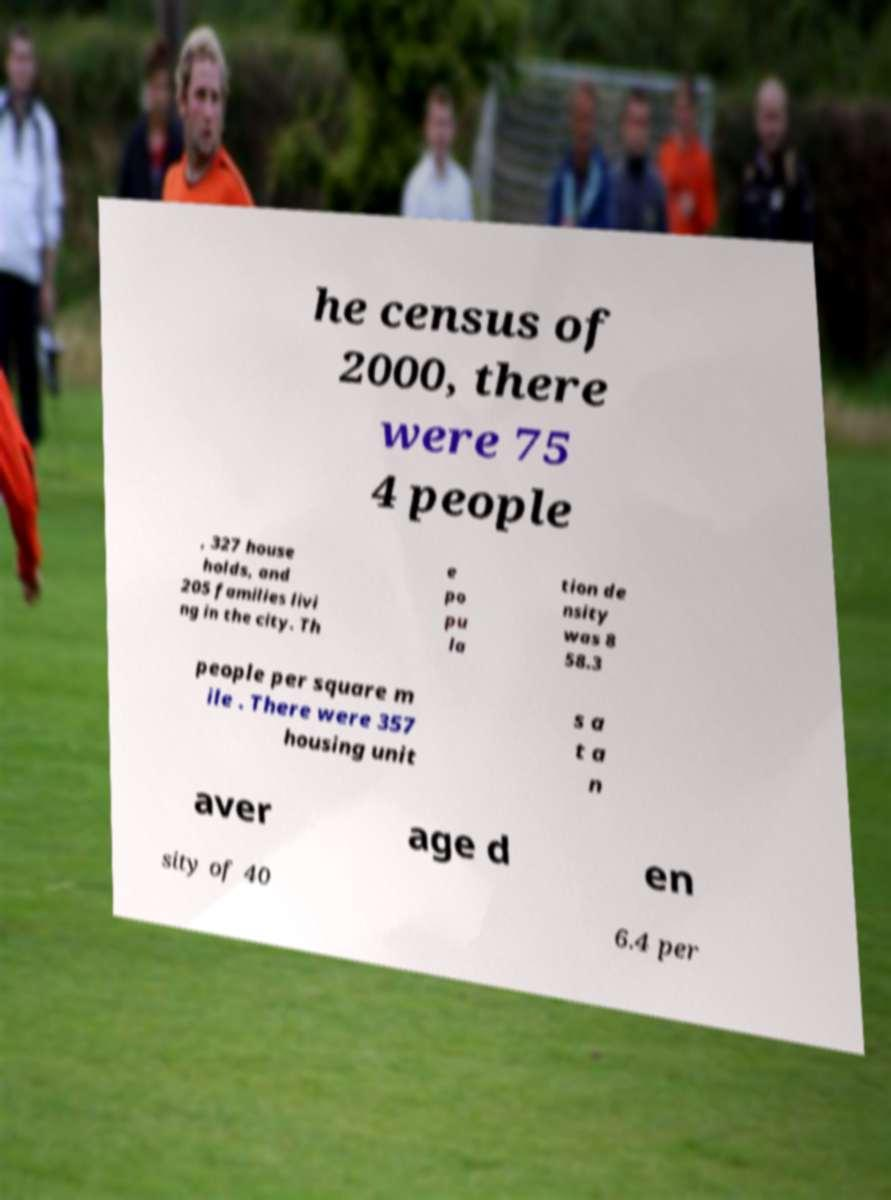Please identify and transcribe the text found in this image. he census of 2000, there were 75 4 people , 327 house holds, and 205 families livi ng in the city. Th e po pu la tion de nsity was 8 58.3 people per square m ile . There were 357 housing unit s a t a n aver age d en sity of 40 6.4 per 